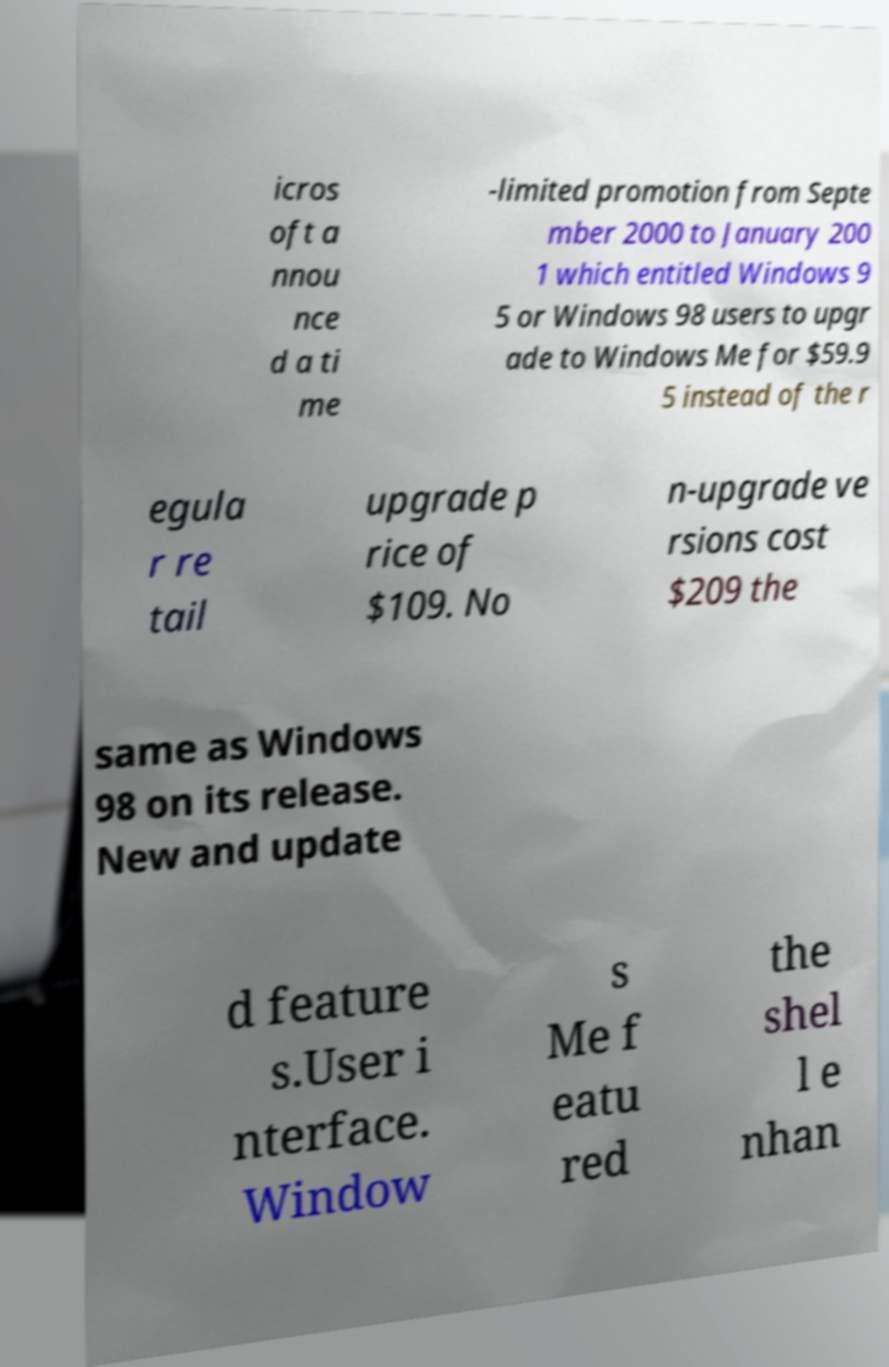Can you read and provide the text displayed in the image?This photo seems to have some interesting text. Can you extract and type it out for me? icros oft a nnou nce d a ti me -limited promotion from Septe mber 2000 to January 200 1 which entitled Windows 9 5 or Windows 98 users to upgr ade to Windows Me for $59.9 5 instead of the r egula r re tail upgrade p rice of $109. No n-upgrade ve rsions cost $209 the same as Windows 98 on its release. New and update d feature s.User i nterface. Window s Me f eatu red the shel l e nhan 